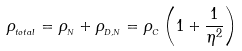<formula> <loc_0><loc_0><loc_500><loc_500>\rho _ { _ { t o t a l } } = \rho _ { _ { N } } + \rho _ { _ { D , N } } = \rho _ { _ { C } } \left ( 1 + \frac { 1 } { \eta ^ { 2 } } \right )</formula> 